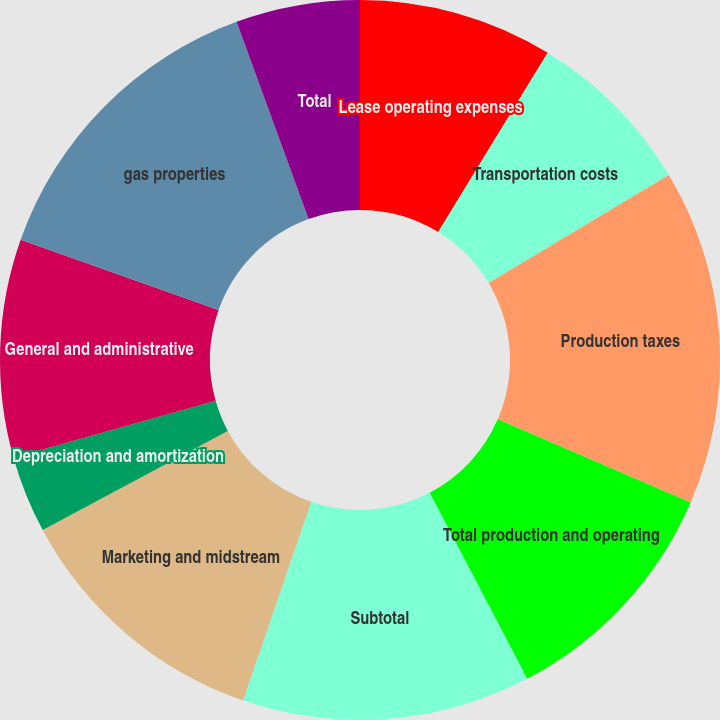Convert chart to OTSL. <chart><loc_0><loc_0><loc_500><loc_500><pie_chart><fcel>Lease operating expenses<fcel>Transportation costs<fcel>Production taxes<fcel>Total production and operating<fcel>Subtotal<fcel>Marketing and midstream<fcel>Depreciation and amortization<fcel>General and administrative<fcel>gas properties<fcel>Total<nl><fcel>8.73%<fcel>7.68%<fcel>15.06%<fcel>10.84%<fcel>12.95%<fcel>11.9%<fcel>3.46%<fcel>9.79%<fcel>14.01%<fcel>5.57%<nl></chart> 